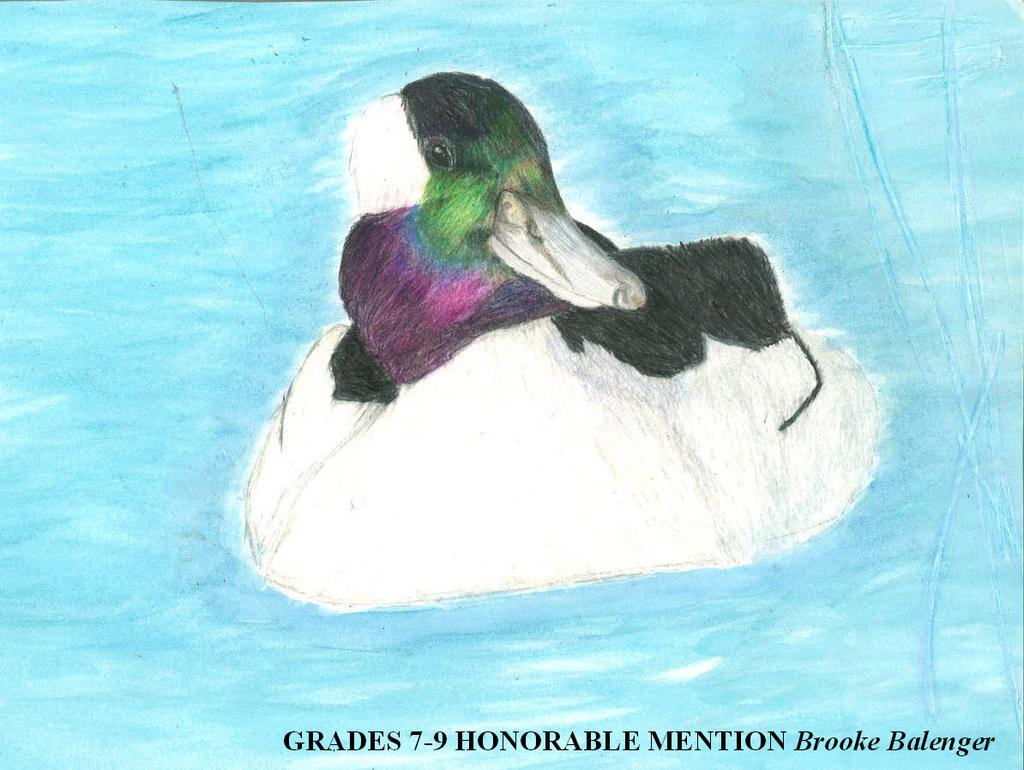What is the main subject of the drawing in the image? There is a drawing of a duck in the image. Where is the duck located in the drawing? The duck is depicted in water. Can you describe any additional features of the image? There is a watermark on the image. What type of cord is being used to keep the duck from flying away in the image? There is no cord present in the image, and the duck is not depicted as being restrained. 